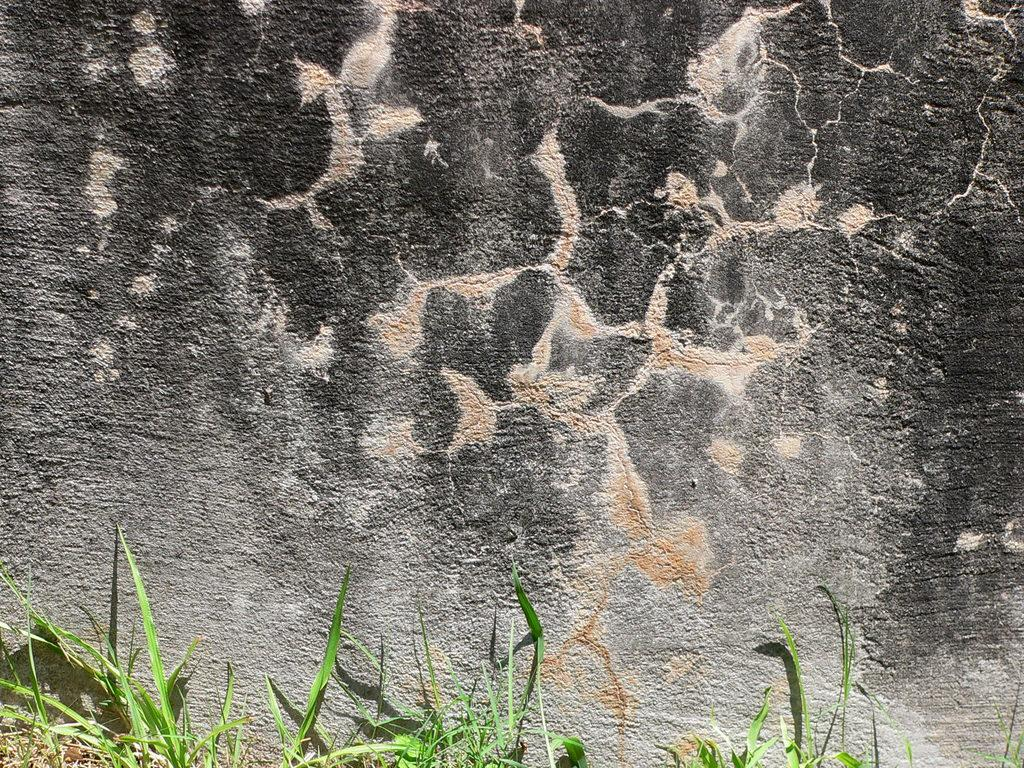What type of vegetation is at the bottom of the image? There is grass at the bottom of the image. What can be seen in the background of the image? There appears to be a rock in the background of the image. What is the rate of the zephyr in the image? There is no zephyr present in the image, so it is not possible to determine its rate. 